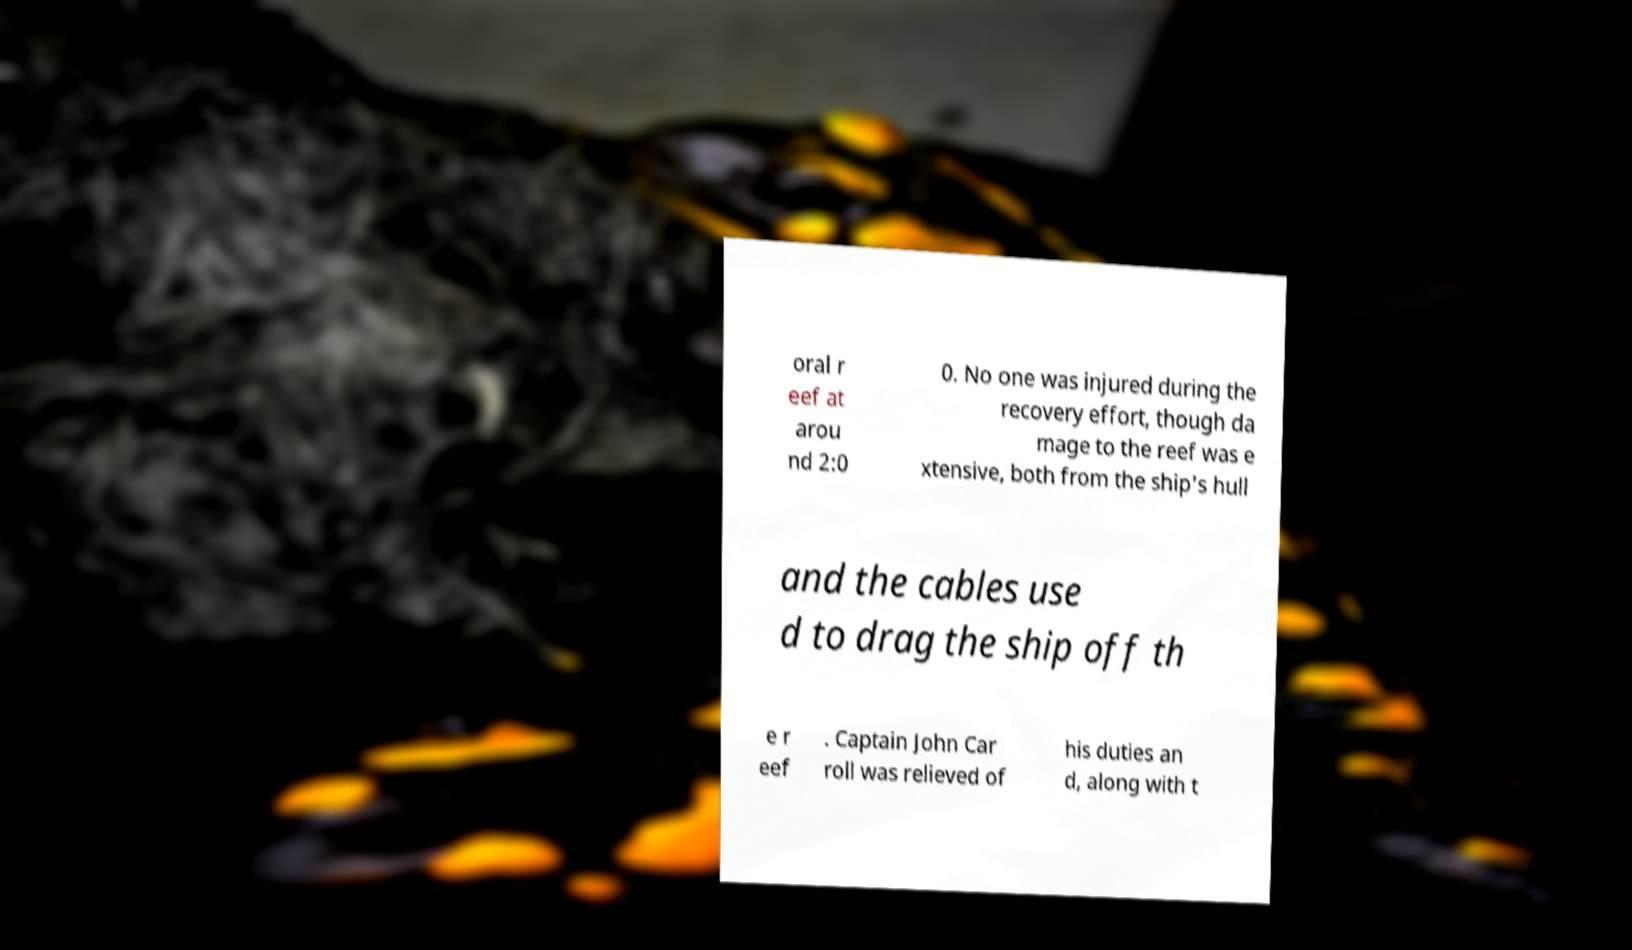Could you extract and type out the text from this image? oral r eef at arou nd 2:0 0. No one was injured during the recovery effort, though da mage to the reef was e xtensive, both from the ship's hull and the cables use d to drag the ship off th e r eef . Captain John Car roll was relieved of his duties an d, along with t 